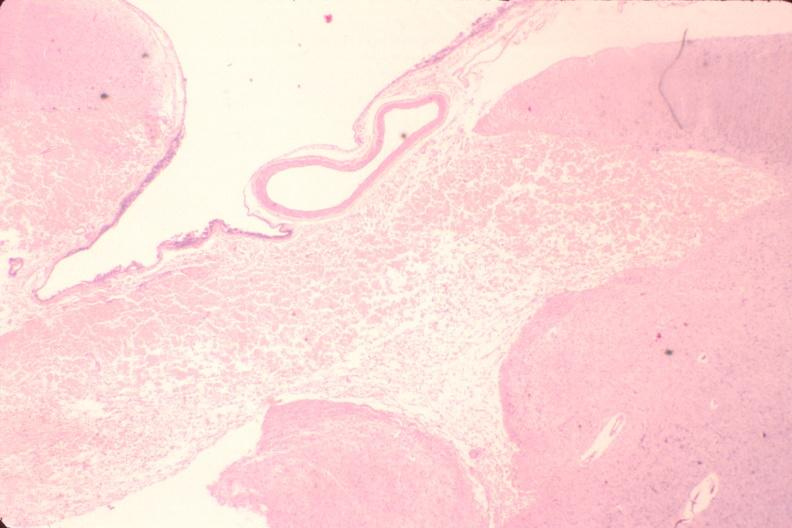does this image show brain, encephalomalasia?
Answer the question using a single word or phrase. Yes 